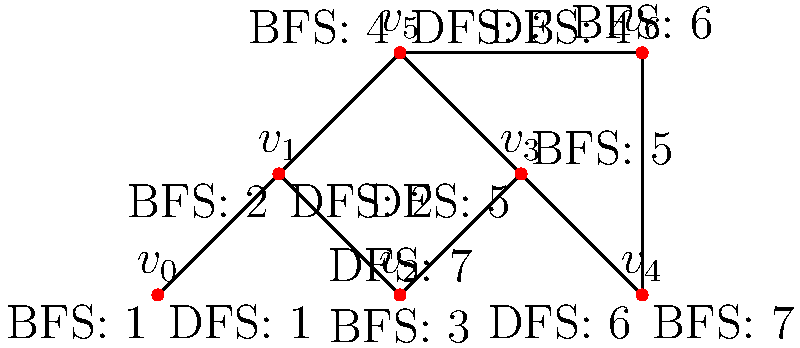Given the graph structure shown above with both Breadth-First Search (BFS) and Depth-First Search (DFS) traversal orders labeled, what is the key difference in how these two algorithms explore the graph, and how does this affect their respective time complexities in terms of $|V|$ (number of vertices) and $|E|$ (number of edges)? To answer this question, let's analyze the traversal patterns and their implications:

1. BFS Traversal:
   - Explores the graph level by level, visiting all neighbors of a vertex before moving to the next level.
   - In the diagram, BFS visits vertices in the order: $v_0, v_1, v_2, v_5, v_3, v_6, v_4$.
   - Uses a queue data structure to keep track of vertices to visit next.

2. DFS Traversal:
   - Explores the graph by going as deep as possible along each branch before backtracking.
   - In the diagram, DFS visits vertices in the order: $v_0, v_1, v_5, v_6, v_3, v_4, v_2$.
   - Uses a stack (or recursion) to keep track of vertices to visit next.

3. Key Difference:
   - BFS explores breadth-wise, while DFS explores depth-wise.
   - This affects the order in which vertices are discovered and can impact the efficiency of certain graph problems.

4. Time Complexity Analysis:
   - Both BFS and DFS have the same time complexity: $O(|V| + |E|)$.
   - This is because both algorithms visit each vertex once $(O(|V|))$ and explore each edge once $(O(|E|))$.
   - The difference in traversal order doesn't affect the overall time complexity for a complete graph traversal.

5. Space Complexity:
   - BFS typically requires more space $(O(|V|))$ due to the queue potentially storing all vertices at a given level.
   - DFS space complexity is $O(h)$, where $h$ is the height of the DFS tree, which in the worst case can be $O(|V|)$.

6. Practical Implications:
   - BFS is often preferred for finding shortest paths in unweighted graphs.
   - DFS is often used for cycle detection, topological sorting, and exploring game trees.

The key difference lies in the exploration pattern, which affects the order of vertex discovery and can impact the efficiency of specific graph algorithms, despite having the same overall time complexity for a complete traversal.
Answer: BFS explores breadth-wise, DFS explores depth-wise; both have $O(|V| + |E|)$ time complexity. 